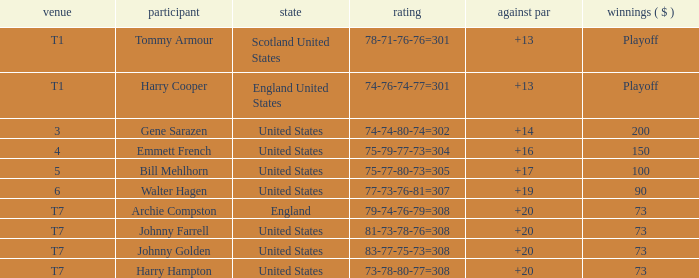What is the ranking for the United States when the money is $200? 3.0. 